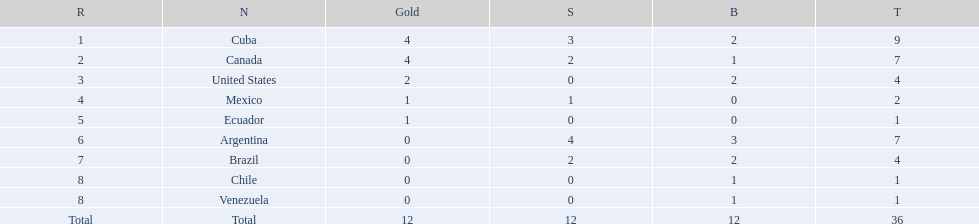Which nation obtained the largest accumulation of bronze medals? Argentina. 